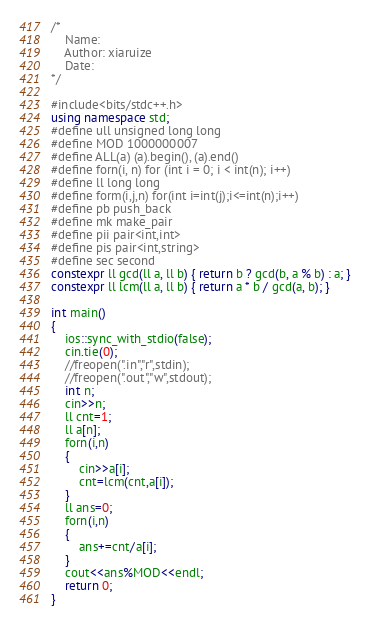<code> <loc_0><loc_0><loc_500><loc_500><_C++_>/*
	Name:
	Author: xiaruize
	Date:
*/

#include<bits/stdc++.h>
using namespace std;
#define ull unsigned long long
#define MOD 1000000007
#define ALL(a) (a).begin(), (a).end()
#define forn(i, n) for (int i = 0; i < int(n); i++)
#define ll long long
#define form(i,j,n) for(int i=int(j);i<=int(n);i++)
#define pb push_back
#define mk make_pair
#define pii pair<int,int>
#define pis pair<int,string>
#define sec second
constexpr ll gcd(ll a, ll b) { return b ? gcd(b, a % b) : a; }
constexpr ll lcm(ll a, ll b) { return a * b / gcd(a, b); }

int main()
{
 	ios::sync_with_stdio(false);
	cin.tie(0);
 	//freopen(".in","r",stdin);
	//freopen(".out","w",stdout);
	int n;
	cin>>n;
	ll cnt=1;
	ll a[n];
	forn(i,n)
	{
		cin>>a[i];
		cnt=lcm(cnt,a[i]);
	}
	ll ans=0;
	forn(i,n)
	{
		ans+=cnt/a[i];
	}
	cout<<ans%MOD<<endl;
	return 0;
}</code> 